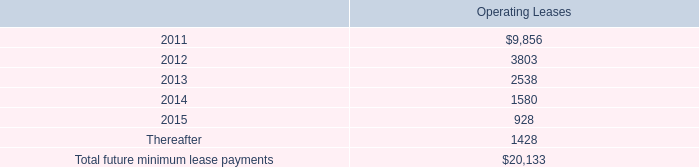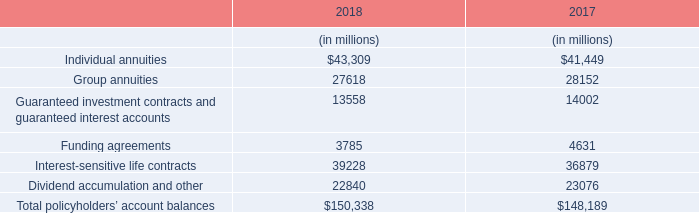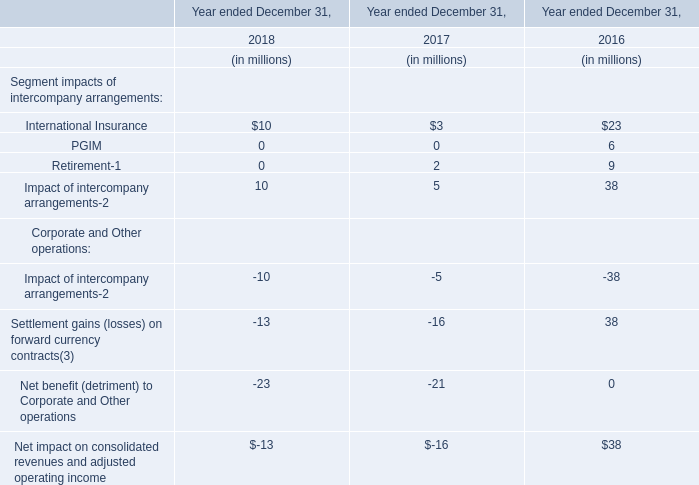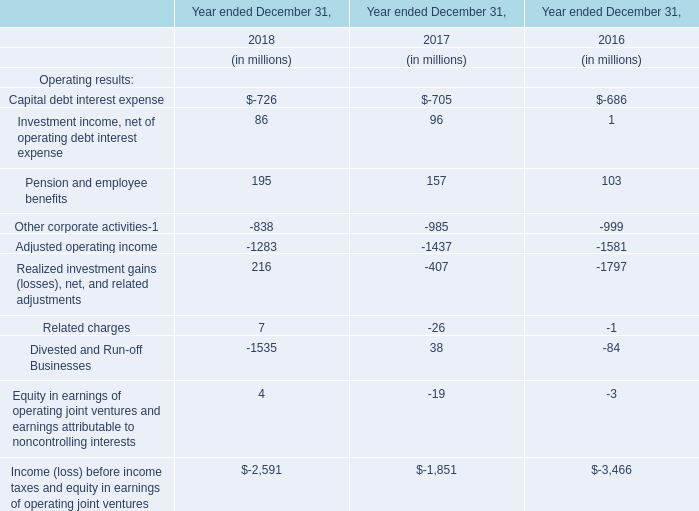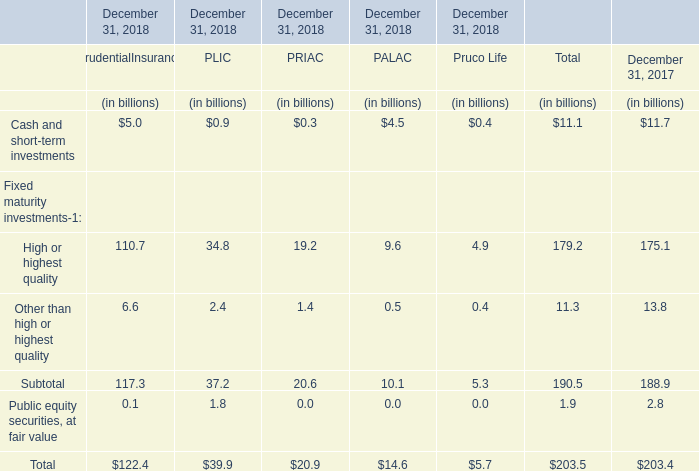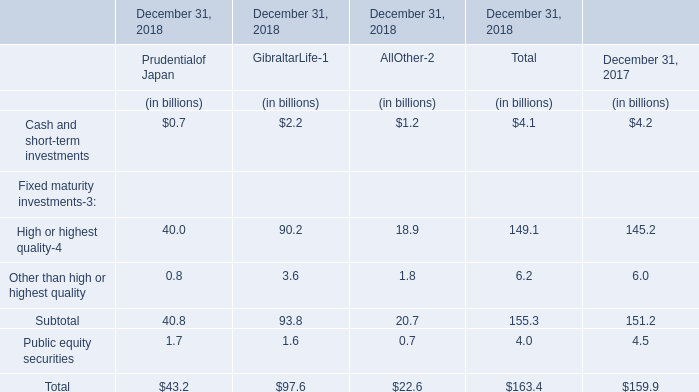what is the percentage change in rent expense from 2009 to 2010? 
Computations: (32.8 - 30.2)
Answer: 2.6. 